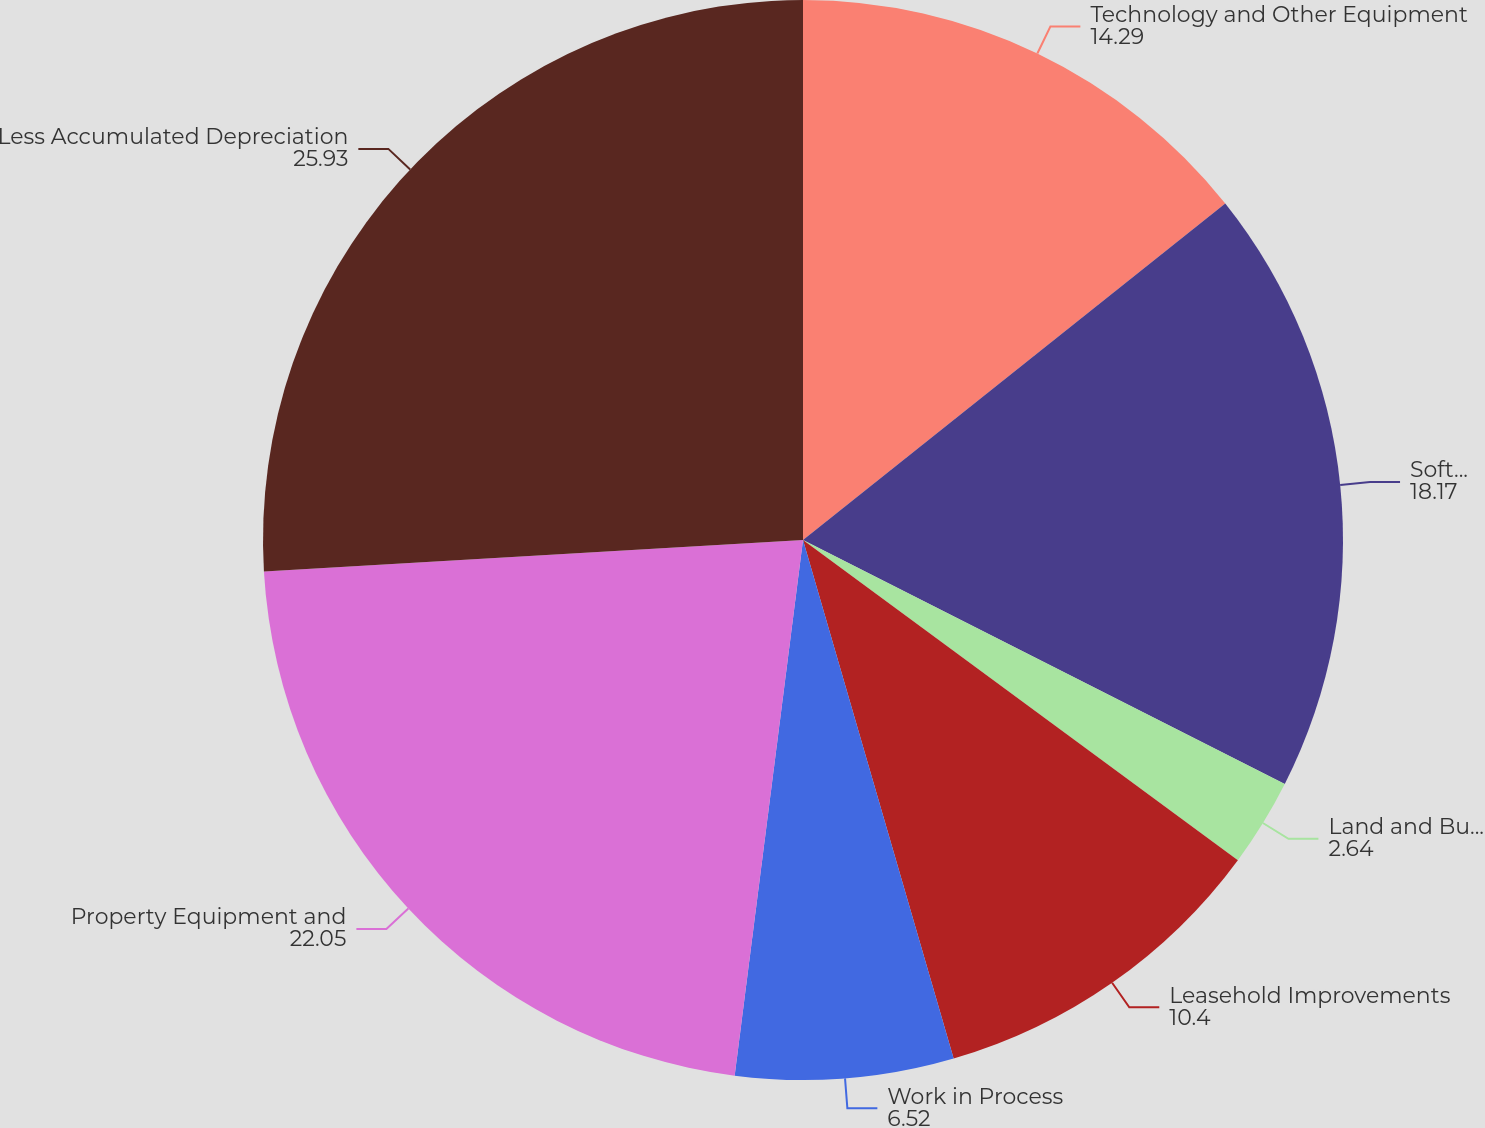<chart> <loc_0><loc_0><loc_500><loc_500><pie_chart><fcel>Technology and Other Equipment<fcel>Software<fcel>Land and Buildings<fcel>Leasehold Improvements<fcel>Work in Process<fcel>Property Equipment and<fcel>Less Accumulated Depreciation<nl><fcel>14.29%<fcel>18.17%<fcel>2.64%<fcel>10.4%<fcel>6.52%<fcel>22.05%<fcel>25.93%<nl></chart> 